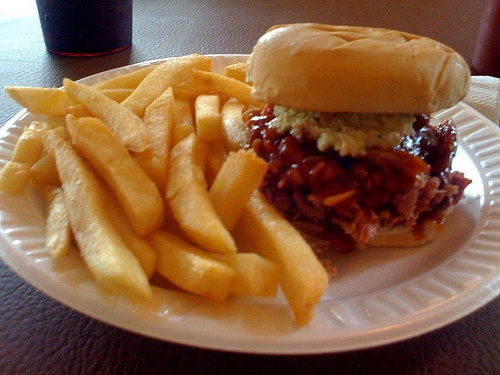Describe the objects in this image and their specific colors. I can see sandwich in white, maroon, brown, black, and tan tones and cup in white, black, navy, maroon, and blue tones in this image. 